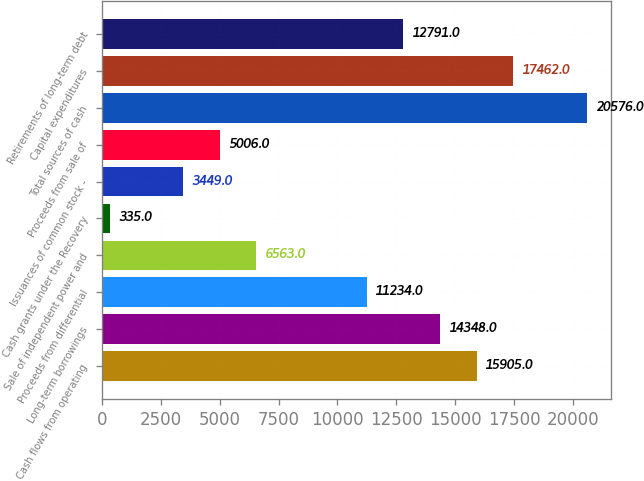<chart> <loc_0><loc_0><loc_500><loc_500><bar_chart><fcel>Cash flows from operating<fcel>Long-term borrowings<fcel>Proceeds from differential<fcel>Sale of independent power and<fcel>Cash grants under the Recovery<fcel>Issuances of common stock -<fcel>Proceeds from sale of<fcel>Total sources of cash<fcel>Capital expenditures<fcel>Retirements of long-term debt<nl><fcel>15905<fcel>14348<fcel>11234<fcel>6563<fcel>335<fcel>3449<fcel>5006<fcel>20576<fcel>17462<fcel>12791<nl></chart> 